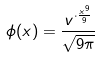<formula> <loc_0><loc_0><loc_500><loc_500>\phi ( x ) = \frac { v ^ { \cdot \frac { x ^ { 9 } } { 9 } } } { \sqrt { 9 \pi } }</formula> 